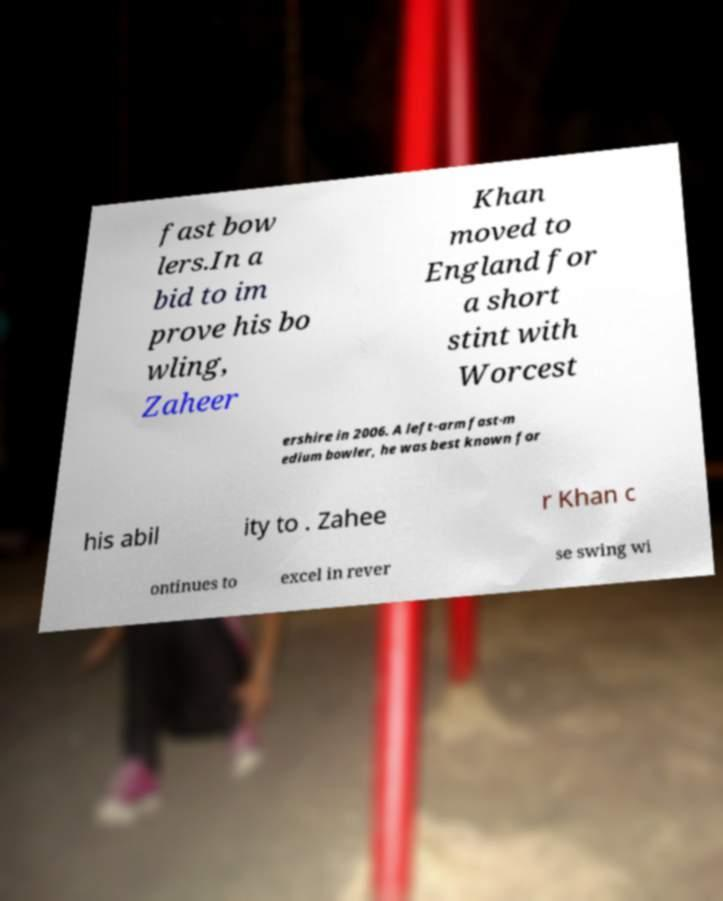Please identify and transcribe the text found in this image. fast bow lers.In a bid to im prove his bo wling, Zaheer Khan moved to England for a short stint with Worcest ershire in 2006. A left-arm fast-m edium bowler, he was best known for his abil ity to . Zahee r Khan c ontinues to excel in rever se swing wi 